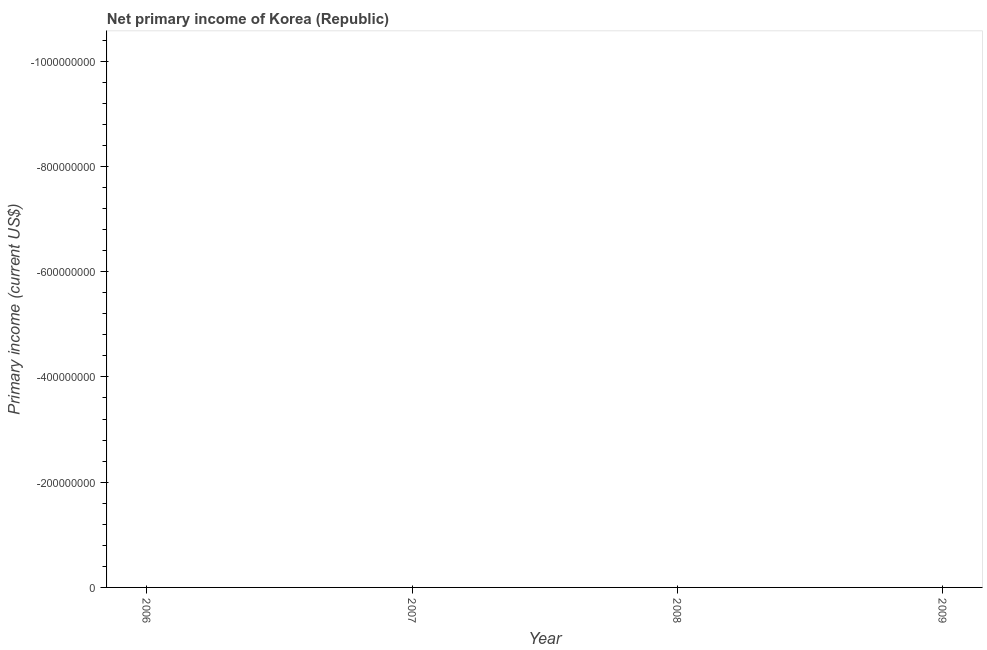What is the amount of primary income in 2006?
Ensure brevity in your answer.  0. Across all years, what is the minimum amount of primary income?
Your answer should be very brief. 0. What is the median amount of primary income?
Keep it short and to the point. 0. In how many years, is the amount of primary income greater than the average amount of primary income taken over all years?
Your answer should be very brief. 0. How many years are there in the graph?
Ensure brevity in your answer.  4. What is the difference between two consecutive major ticks on the Y-axis?
Provide a short and direct response. 2.00e+08. Does the graph contain grids?
Make the answer very short. No. What is the title of the graph?
Keep it short and to the point. Net primary income of Korea (Republic). What is the label or title of the Y-axis?
Offer a terse response. Primary income (current US$). What is the Primary income (current US$) in 2006?
Ensure brevity in your answer.  0. What is the Primary income (current US$) in 2008?
Make the answer very short. 0. 